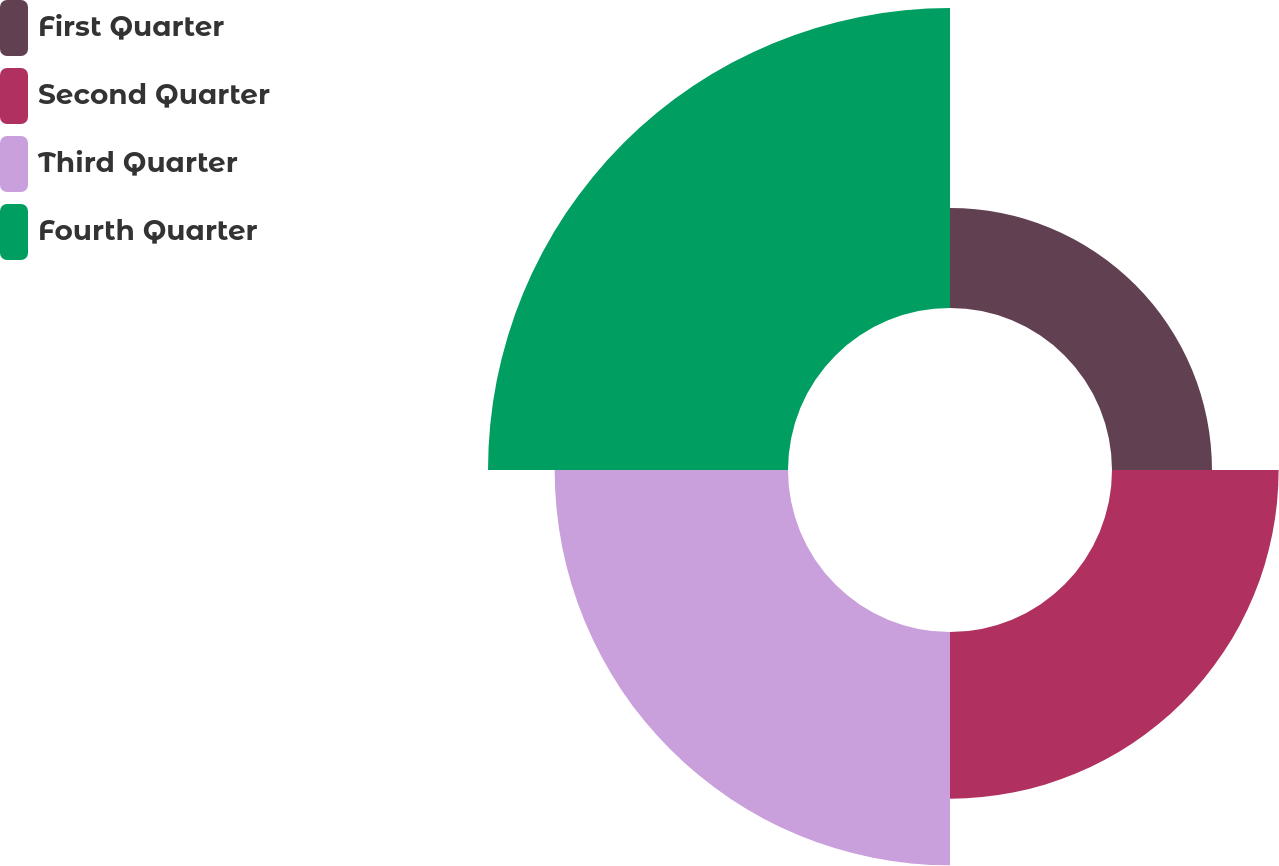Convert chart to OTSL. <chart><loc_0><loc_0><loc_500><loc_500><pie_chart><fcel>First Quarter<fcel>Second Quarter<fcel>Third Quarter<fcel>Fourth Quarter<nl><fcel>12.5%<fcel>20.83%<fcel>29.17%<fcel>37.5%<nl></chart> 